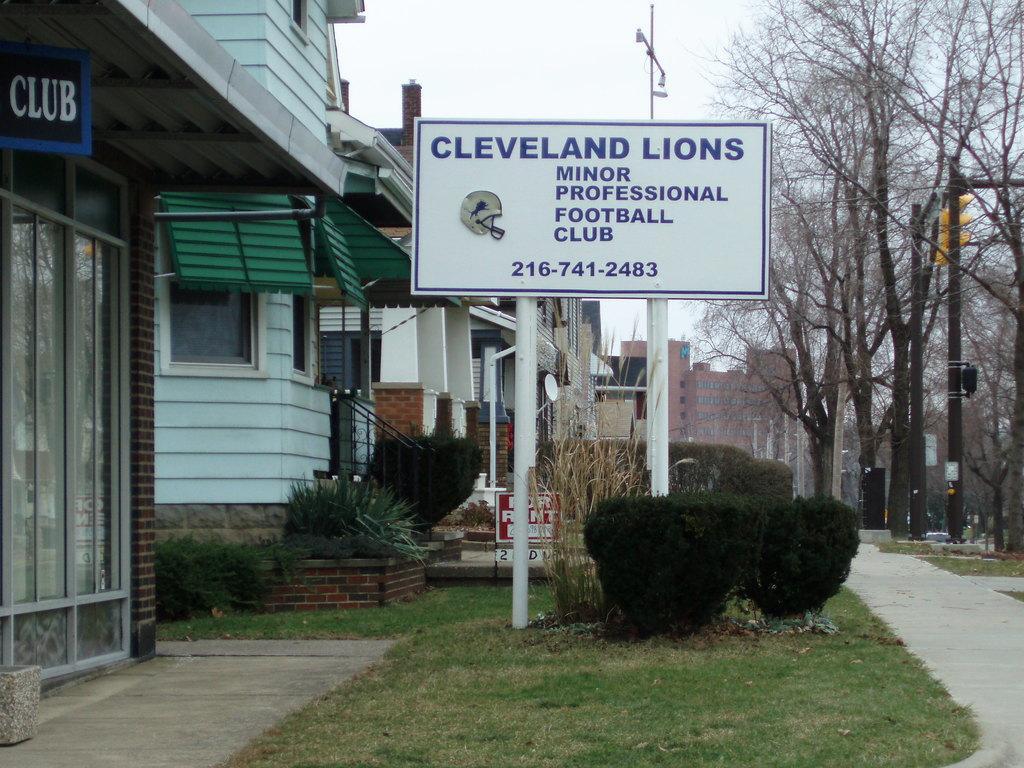Please provide a concise description of this image. In this picture there are buildings on the left side of the image. In the foreground there is a board on the pole and there is a text on the board. On the right side of the image there are trees and poles. At top there is sky. At the bottom there is grass and there are plants. 